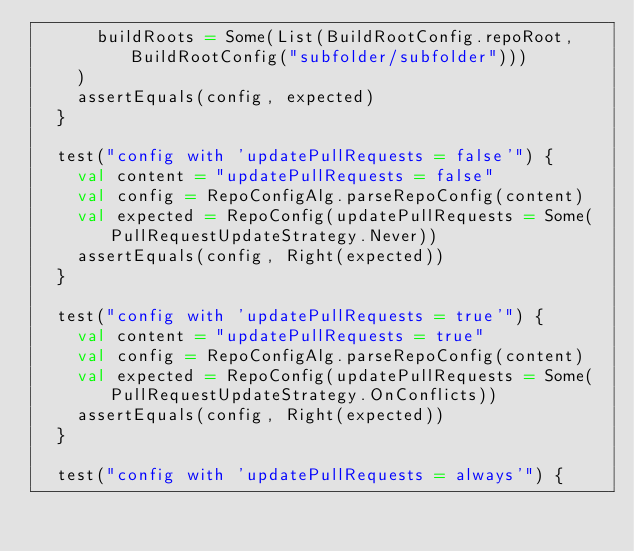Convert code to text. <code><loc_0><loc_0><loc_500><loc_500><_Scala_>      buildRoots = Some(List(BuildRootConfig.repoRoot, BuildRootConfig("subfolder/subfolder")))
    )
    assertEquals(config, expected)
  }

  test("config with 'updatePullRequests = false'") {
    val content = "updatePullRequests = false"
    val config = RepoConfigAlg.parseRepoConfig(content)
    val expected = RepoConfig(updatePullRequests = Some(PullRequestUpdateStrategy.Never))
    assertEquals(config, Right(expected))
  }

  test("config with 'updatePullRequests = true'") {
    val content = "updatePullRequests = true"
    val config = RepoConfigAlg.parseRepoConfig(content)
    val expected = RepoConfig(updatePullRequests = Some(PullRequestUpdateStrategy.OnConflicts))
    assertEquals(config, Right(expected))
  }

  test("config with 'updatePullRequests = always'") {</code> 